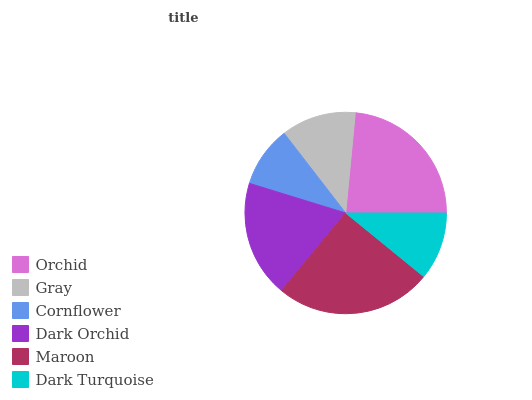Is Cornflower the minimum?
Answer yes or no. Yes. Is Maroon the maximum?
Answer yes or no. Yes. Is Gray the minimum?
Answer yes or no. No. Is Gray the maximum?
Answer yes or no. No. Is Orchid greater than Gray?
Answer yes or no. Yes. Is Gray less than Orchid?
Answer yes or no. Yes. Is Gray greater than Orchid?
Answer yes or no. No. Is Orchid less than Gray?
Answer yes or no. No. Is Dark Orchid the high median?
Answer yes or no. Yes. Is Gray the low median?
Answer yes or no. Yes. Is Maroon the high median?
Answer yes or no. No. Is Dark Turquoise the low median?
Answer yes or no. No. 